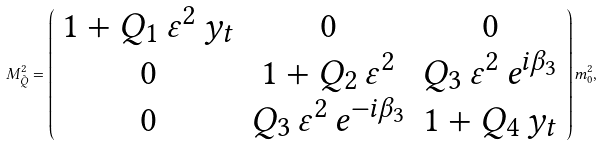<formula> <loc_0><loc_0><loc_500><loc_500>M _ { \tilde { Q } } ^ { 2 } = \left ( \begin{array} { c c c } 1 + Q _ { 1 } \, \varepsilon ^ { 2 } \, y _ { t } & 0 & 0 \\ 0 & 1 + Q _ { 2 } \, \varepsilon ^ { 2 } & Q _ { 3 } \, \varepsilon ^ { 2 } \, e ^ { i \beta _ { 3 } } \\ 0 & Q _ { 3 } \, \varepsilon ^ { 2 } \, e ^ { - i \beta _ { 3 } } & 1 + Q _ { 4 } \, y _ { t } \end{array} \right ) m _ { 0 } ^ { 2 } ,</formula> 